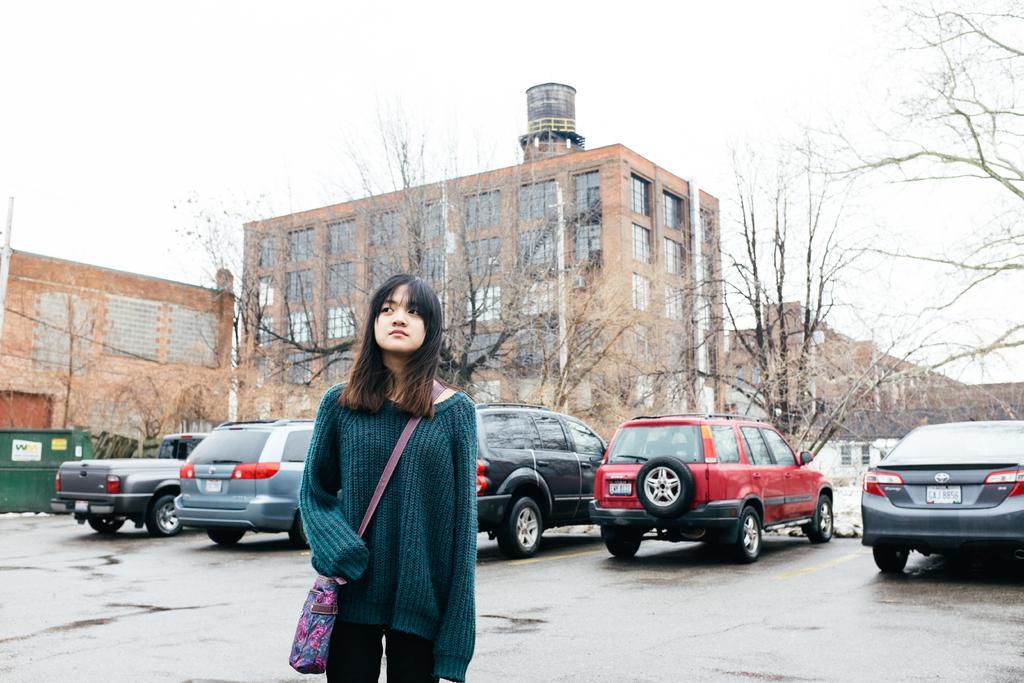Describe this image in one or two sentences. In this image, we can see a person wearing a sling bag. In the background, we can see buildings, trees, walls, windows, vehicles and the sky. 